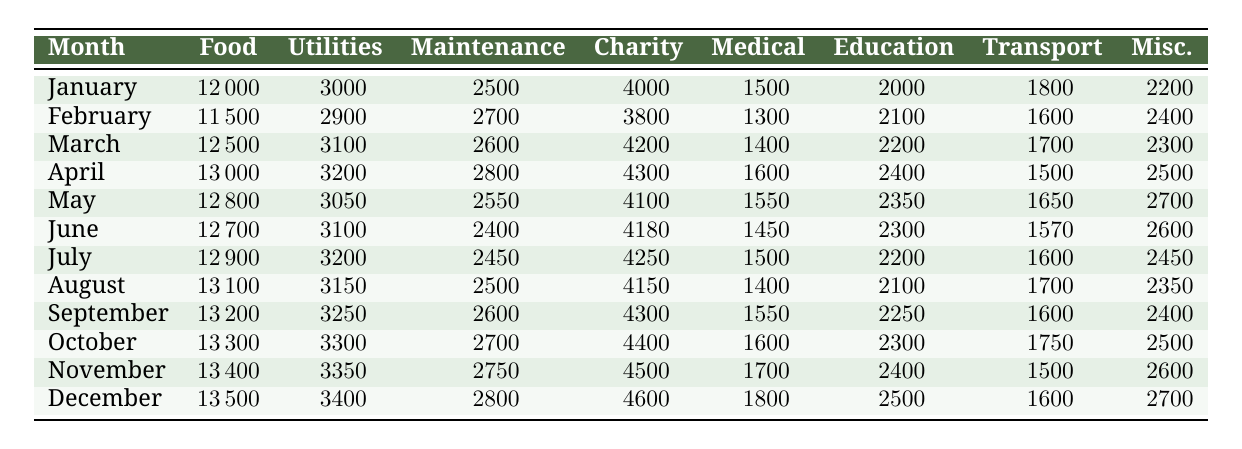What was the total food expense for the first three months? To find the total food expense for January, February, and March, we add the values: January (12000) + February (11500) + March (12500) = 36000.
Answer: 36000 In which month did the monastery spend the most on utilities? By examining the utilities expenses for each month, we see that December (3400) has the highest value compared to other months.
Answer: December What is the average charity expense per month over the year? To calculate the average charity expense, we sum up all the charity expenses: (4000 + 3800 + 4200 + 4300 + 4100 + 4180 + 4250 + 4150 + 4300 + 4400 + 4500 + 4600) = 51680. There are 12 months, so the average is 51680 / 12 = 4306.67.
Answer: 4306.67 Did the maintenance expenses increase in September compared to August? The maintenance expenses for September were 2600, while for August, they were 2500. Since 2600 is greater than 2500, this indicates an increase.
Answer: Yes What was the overall trend in education expenses from January to December? Looking at the education expenses for each month, they begin at 2000 in January and gradually rise to 2500 in December, indicating a consistent upward trend over the year.
Answer: Increasing trend 